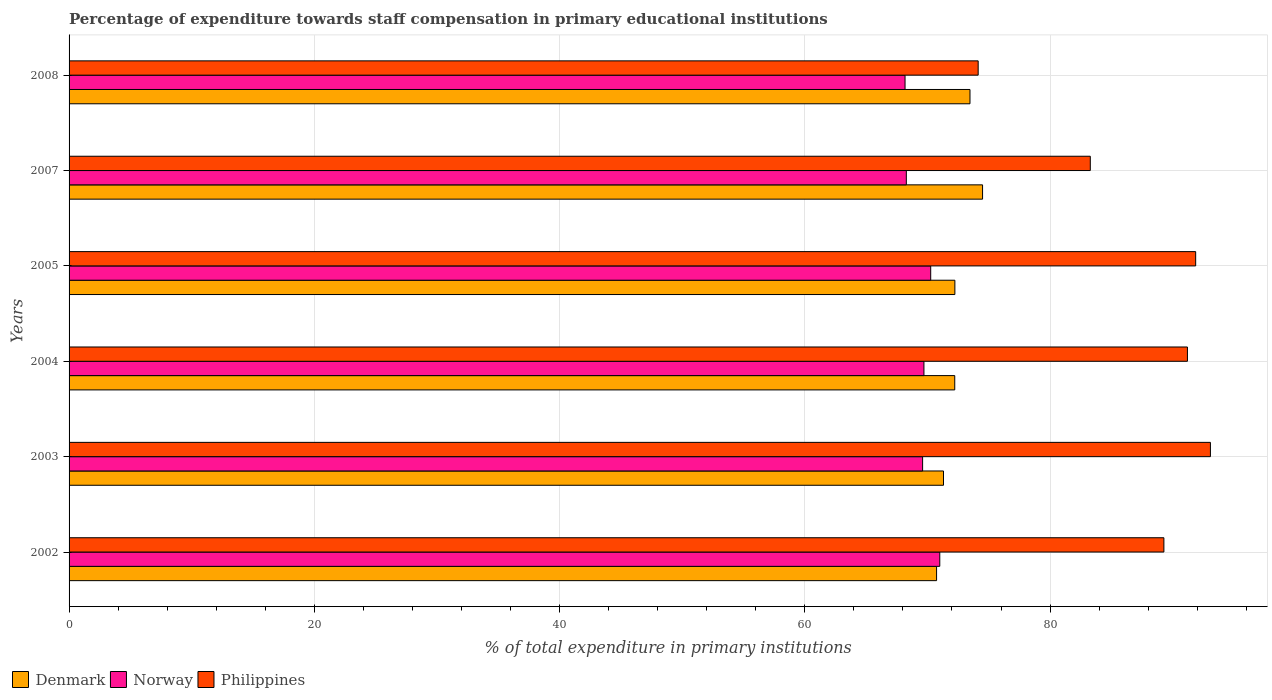How many bars are there on the 6th tick from the top?
Provide a succinct answer. 3. How many bars are there on the 2nd tick from the bottom?
Give a very brief answer. 3. What is the label of the 1st group of bars from the top?
Your response must be concise. 2008. In how many cases, is the number of bars for a given year not equal to the number of legend labels?
Offer a very short reply. 0. What is the percentage of expenditure towards staff compensation in Philippines in 2004?
Give a very brief answer. 91.2. Across all years, what is the maximum percentage of expenditure towards staff compensation in Norway?
Offer a terse response. 71.01. Across all years, what is the minimum percentage of expenditure towards staff compensation in Denmark?
Your response must be concise. 70.75. What is the total percentage of expenditure towards staff compensation in Denmark in the graph?
Offer a terse response. 434.49. What is the difference between the percentage of expenditure towards staff compensation in Philippines in 2003 and that in 2005?
Offer a very short reply. 1.2. What is the difference between the percentage of expenditure towards staff compensation in Norway in 2004 and the percentage of expenditure towards staff compensation in Philippines in 2005?
Keep it short and to the point. -22.16. What is the average percentage of expenditure towards staff compensation in Norway per year?
Provide a succinct answer. 69.51. In the year 2007, what is the difference between the percentage of expenditure towards staff compensation in Philippines and percentage of expenditure towards staff compensation in Denmark?
Provide a short and direct response. 8.79. What is the ratio of the percentage of expenditure towards staff compensation in Norway in 2002 to that in 2003?
Offer a terse response. 1.02. What is the difference between the highest and the second highest percentage of expenditure towards staff compensation in Denmark?
Your answer should be very brief. 1.03. What is the difference between the highest and the lowest percentage of expenditure towards staff compensation in Norway?
Ensure brevity in your answer.  2.83. In how many years, is the percentage of expenditure towards staff compensation in Denmark greater than the average percentage of expenditure towards staff compensation in Denmark taken over all years?
Your answer should be very brief. 2. Is the sum of the percentage of expenditure towards staff compensation in Philippines in 2005 and 2007 greater than the maximum percentage of expenditure towards staff compensation in Norway across all years?
Provide a succinct answer. Yes. What does the 2nd bar from the bottom in 2007 represents?
Provide a short and direct response. Norway. Are all the bars in the graph horizontal?
Your answer should be very brief. Yes. What is the difference between two consecutive major ticks on the X-axis?
Offer a terse response. 20. Does the graph contain any zero values?
Provide a succinct answer. No. Where does the legend appear in the graph?
Your answer should be compact. Bottom left. How are the legend labels stacked?
Offer a very short reply. Horizontal. What is the title of the graph?
Offer a terse response. Percentage of expenditure towards staff compensation in primary educational institutions. What is the label or title of the X-axis?
Provide a succinct answer. % of total expenditure in primary institutions. What is the % of total expenditure in primary institutions of Denmark in 2002?
Provide a short and direct response. 70.75. What is the % of total expenditure in primary institutions in Norway in 2002?
Ensure brevity in your answer.  71.01. What is the % of total expenditure in primary institutions in Philippines in 2002?
Offer a terse response. 89.28. What is the % of total expenditure in primary institutions in Denmark in 2003?
Give a very brief answer. 71.31. What is the % of total expenditure in primary institutions of Norway in 2003?
Your answer should be compact. 69.61. What is the % of total expenditure in primary institutions of Philippines in 2003?
Provide a succinct answer. 93.08. What is the % of total expenditure in primary institutions of Denmark in 2004?
Provide a succinct answer. 72.23. What is the % of total expenditure in primary institutions in Norway in 2004?
Provide a short and direct response. 69.71. What is the % of total expenditure in primary institutions in Philippines in 2004?
Give a very brief answer. 91.2. What is the % of total expenditure in primary institutions of Denmark in 2005?
Give a very brief answer. 72.24. What is the % of total expenditure in primary institutions of Norway in 2005?
Your response must be concise. 70.27. What is the % of total expenditure in primary institutions of Philippines in 2005?
Provide a short and direct response. 91.88. What is the % of total expenditure in primary institutions in Denmark in 2007?
Provide a succinct answer. 74.5. What is the % of total expenditure in primary institutions of Norway in 2007?
Your answer should be compact. 68.28. What is the % of total expenditure in primary institutions in Philippines in 2007?
Make the answer very short. 83.28. What is the % of total expenditure in primary institutions of Denmark in 2008?
Provide a short and direct response. 73.47. What is the % of total expenditure in primary institutions of Norway in 2008?
Offer a very short reply. 68.17. What is the % of total expenditure in primary institutions in Philippines in 2008?
Your answer should be very brief. 74.14. Across all years, what is the maximum % of total expenditure in primary institutions in Denmark?
Provide a short and direct response. 74.5. Across all years, what is the maximum % of total expenditure in primary institutions in Norway?
Offer a terse response. 71.01. Across all years, what is the maximum % of total expenditure in primary institutions of Philippines?
Keep it short and to the point. 93.08. Across all years, what is the minimum % of total expenditure in primary institutions of Denmark?
Offer a very short reply. 70.75. Across all years, what is the minimum % of total expenditure in primary institutions of Norway?
Make the answer very short. 68.17. Across all years, what is the minimum % of total expenditure in primary institutions of Philippines?
Provide a short and direct response. 74.14. What is the total % of total expenditure in primary institutions of Denmark in the graph?
Your answer should be very brief. 434.49. What is the total % of total expenditure in primary institutions of Norway in the graph?
Give a very brief answer. 417.05. What is the total % of total expenditure in primary institutions in Philippines in the graph?
Your answer should be compact. 522.86. What is the difference between the % of total expenditure in primary institutions of Denmark in 2002 and that in 2003?
Give a very brief answer. -0.56. What is the difference between the % of total expenditure in primary institutions of Norway in 2002 and that in 2003?
Offer a terse response. 1.4. What is the difference between the % of total expenditure in primary institutions of Philippines in 2002 and that in 2003?
Ensure brevity in your answer.  -3.79. What is the difference between the % of total expenditure in primary institutions in Denmark in 2002 and that in 2004?
Your response must be concise. -1.48. What is the difference between the % of total expenditure in primary institutions in Norway in 2002 and that in 2004?
Provide a short and direct response. 1.29. What is the difference between the % of total expenditure in primary institutions of Philippines in 2002 and that in 2004?
Offer a very short reply. -1.92. What is the difference between the % of total expenditure in primary institutions of Denmark in 2002 and that in 2005?
Offer a very short reply. -1.49. What is the difference between the % of total expenditure in primary institutions of Norway in 2002 and that in 2005?
Offer a very short reply. 0.74. What is the difference between the % of total expenditure in primary institutions in Philippines in 2002 and that in 2005?
Provide a succinct answer. -2.59. What is the difference between the % of total expenditure in primary institutions in Denmark in 2002 and that in 2007?
Offer a terse response. -3.75. What is the difference between the % of total expenditure in primary institutions in Norway in 2002 and that in 2007?
Offer a terse response. 2.73. What is the difference between the % of total expenditure in primary institutions of Philippines in 2002 and that in 2007?
Give a very brief answer. 6. What is the difference between the % of total expenditure in primary institutions of Denmark in 2002 and that in 2008?
Give a very brief answer. -2.72. What is the difference between the % of total expenditure in primary institutions in Norway in 2002 and that in 2008?
Your answer should be very brief. 2.83. What is the difference between the % of total expenditure in primary institutions in Philippines in 2002 and that in 2008?
Ensure brevity in your answer.  15.15. What is the difference between the % of total expenditure in primary institutions of Denmark in 2003 and that in 2004?
Ensure brevity in your answer.  -0.92. What is the difference between the % of total expenditure in primary institutions in Norway in 2003 and that in 2004?
Your answer should be very brief. -0.11. What is the difference between the % of total expenditure in primary institutions of Philippines in 2003 and that in 2004?
Keep it short and to the point. 1.87. What is the difference between the % of total expenditure in primary institutions of Denmark in 2003 and that in 2005?
Make the answer very short. -0.93. What is the difference between the % of total expenditure in primary institutions in Norway in 2003 and that in 2005?
Ensure brevity in your answer.  -0.66. What is the difference between the % of total expenditure in primary institutions of Philippines in 2003 and that in 2005?
Offer a very short reply. 1.2. What is the difference between the % of total expenditure in primary institutions of Denmark in 2003 and that in 2007?
Offer a terse response. -3.19. What is the difference between the % of total expenditure in primary institutions in Norway in 2003 and that in 2007?
Provide a succinct answer. 1.33. What is the difference between the % of total expenditure in primary institutions of Philippines in 2003 and that in 2007?
Make the answer very short. 9.8. What is the difference between the % of total expenditure in primary institutions of Denmark in 2003 and that in 2008?
Give a very brief answer. -2.16. What is the difference between the % of total expenditure in primary institutions in Norway in 2003 and that in 2008?
Provide a succinct answer. 1.43. What is the difference between the % of total expenditure in primary institutions in Philippines in 2003 and that in 2008?
Ensure brevity in your answer.  18.94. What is the difference between the % of total expenditure in primary institutions of Denmark in 2004 and that in 2005?
Your answer should be very brief. -0.01. What is the difference between the % of total expenditure in primary institutions of Norway in 2004 and that in 2005?
Make the answer very short. -0.55. What is the difference between the % of total expenditure in primary institutions in Philippines in 2004 and that in 2005?
Provide a short and direct response. -0.67. What is the difference between the % of total expenditure in primary institutions in Denmark in 2004 and that in 2007?
Give a very brief answer. -2.27. What is the difference between the % of total expenditure in primary institutions in Norway in 2004 and that in 2007?
Provide a short and direct response. 1.44. What is the difference between the % of total expenditure in primary institutions in Philippines in 2004 and that in 2007?
Provide a succinct answer. 7.92. What is the difference between the % of total expenditure in primary institutions of Denmark in 2004 and that in 2008?
Ensure brevity in your answer.  -1.24. What is the difference between the % of total expenditure in primary institutions in Norway in 2004 and that in 2008?
Offer a very short reply. 1.54. What is the difference between the % of total expenditure in primary institutions in Philippines in 2004 and that in 2008?
Provide a succinct answer. 17.07. What is the difference between the % of total expenditure in primary institutions of Denmark in 2005 and that in 2007?
Your response must be concise. -2.26. What is the difference between the % of total expenditure in primary institutions of Norway in 2005 and that in 2007?
Provide a succinct answer. 1.99. What is the difference between the % of total expenditure in primary institutions of Philippines in 2005 and that in 2007?
Give a very brief answer. 8.59. What is the difference between the % of total expenditure in primary institutions in Denmark in 2005 and that in 2008?
Make the answer very short. -1.23. What is the difference between the % of total expenditure in primary institutions in Norway in 2005 and that in 2008?
Provide a succinct answer. 2.09. What is the difference between the % of total expenditure in primary institutions in Philippines in 2005 and that in 2008?
Ensure brevity in your answer.  17.74. What is the difference between the % of total expenditure in primary institutions in Denmark in 2007 and that in 2008?
Provide a short and direct response. 1.03. What is the difference between the % of total expenditure in primary institutions of Norway in 2007 and that in 2008?
Offer a very short reply. 0.11. What is the difference between the % of total expenditure in primary institutions in Philippines in 2007 and that in 2008?
Offer a terse response. 9.14. What is the difference between the % of total expenditure in primary institutions in Denmark in 2002 and the % of total expenditure in primary institutions in Norway in 2003?
Offer a terse response. 1.14. What is the difference between the % of total expenditure in primary institutions in Denmark in 2002 and the % of total expenditure in primary institutions in Philippines in 2003?
Provide a succinct answer. -22.33. What is the difference between the % of total expenditure in primary institutions of Norway in 2002 and the % of total expenditure in primary institutions of Philippines in 2003?
Provide a succinct answer. -22.07. What is the difference between the % of total expenditure in primary institutions of Denmark in 2002 and the % of total expenditure in primary institutions of Norway in 2004?
Offer a terse response. 1.03. What is the difference between the % of total expenditure in primary institutions of Denmark in 2002 and the % of total expenditure in primary institutions of Philippines in 2004?
Your answer should be very brief. -20.46. What is the difference between the % of total expenditure in primary institutions in Norway in 2002 and the % of total expenditure in primary institutions in Philippines in 2004?
Provide a short and direct response. -20.2. What is the difference between the % of total expenditure in primary institutions in Denmark in 2002 and the % of total expenditure in primary institutions in Norway in 2005?
Your response must be concise. 0.48. What is the difference between the % of total expenditure in primary institutions in Denmark in 2002 and the % of total expenditure in primary institutions in Philippines in 2005?
Give a very brief answer. -21.13. What is the difference between the % of total expenditure in primary institutions in Norway in 2002 and the % of total expenditure in primary institutions in Philippines in 2005?
Provide a succinct answer. -20.87. What is the difference between the % of total expenditure in primary institutions of Denmark in 2002 and the % of total expenditure in primary institutions of Norway in 2007?
Make the answer very short. 2.47. What is the difference between the % of total expenditure in primary institutions in Denmark in 2002 and the % of total expenditure in primary institutions in Philippines in 2007?
Offer a very short reply. -12.54. What is the difference between the % of total expenditure in primary institutions in Norway in 2002 and the % of total expenditure in primary institutions in Philippines in 2007?
Provide a short and direct response. -12.27. What is the difference between the % of total expenditure in primary institutions of Denmark in 2002 and the % of total expenditure in primary institutions of Norway in 2008?
Your answer should be compact. 2.57. What is the difference between the % of total expenditure in primary institutions in Denmark in 2002 and the % of total expenditure in primary institutions in Philippines in 2008?
Give a very brief answer. -3.39. What is the difference between the % of total expenditure in primary institutions of Norway in 2002 and the % of total expenditure in primary institutions of Philippines in 2008?
Keep it short and to the point. -3.13. What is the difference between the % of total expenditure in primary institutions of Denmark in 2003 and the % of total expenditure in primary institutions of Norway in 2004?
Offer a terse response. 1.6. What is the difference between the % of total expenditure in primary institutions of Denmark in 2003 and the % of total expenditure in primary institutions of Philippines in 2004?
Keep it short and to the point. -19.89. What is the difference between the % of total expenditure in primary institutions in Norway in 2003 and the % of total expenditure in primary institutions in Philippines in 2004?
Keep it short and to the point. -21.6. What is the difference between the % of total expenditure in primary institutions of Denmark in 2003 and the % of total expenditure in primary institutions of Norway in 2005?
Offer a terse response. 1.04. What is the difference between the % of total expenditure in primary institutions of Denmark in 2003 and the % of total expenditure in primary institutions of Philippines in 2005?
Make the answer very short. -20.57. What is the difference between the % of total expenditure in primary institutions in Norway in 2003 and the % of total expenditure in primary institutions in Philippines in 2005?
Your answer should be compact. -22.27. What is the difference between the % of total expenditure in primary institutions in Denmark in 2003 and the % of total expenditure in primary institutions in Norway in 2007?
Keep it short and to the point. 3.03. What is the difference between the % of total expenditure in primary institutions in Denmark in 2003 and the % of total expenditure in primary institutions in Philippines in 2007?
Provide a short and direct response. -11.97. What is the difference between the % of total expenditure in primary institutions in Norway in 2003 and the % of total expenditure in primary institutions in Philippines in 2007?
Offer a very short reply. -13.67. What is the difference between the % of total expenditure in primary institutions of Denmark in 2003 and the % of total expenditure in primary institutions of Norway in 2008?
Your answer should be very brief. 3.14. What is the difference between the % of total expenditure in primary institutions in Denmark in 2003 and the % of total expenditure in primary institutions in Philippines in 2008?
Keep it short and to the point. -2.83. What is the difference between the % of total expenditure in primary institutions of Norway in 2003 and the % of total expenditure in primary institutions of Philippines in 2008?
Ensure brevity in your answer.  -4.53. What is the difference between the % of total expenditure in primary institutions of Denmark in 2004 and the % of total expenditure in primary institutions of Norway in 2005?
Offer a very short reply. 1.96. What is the difference between the % of total expenditure in primary institutions in Denmark in 2004 and the % of total expenditure in primary institutions in Philippines in 2005?
Offer a terse response. -19.65. What is the difference between the % of total expenditure in primary institutions in Norway in 2004 and the % of total expenditure in primary institutions in Philippines in 2005?
Make the answer very short. -22.16. What is the difference between the % of total expenditure in primary institutions in Denmark in 2004 and the % of total expenditure in primary institutions in Norway in 2007?
Your response must be concise. 3.95. What is the difference between the % of total expenditure in primary institutions in Denmark in 2004 and the % of total expenditure in primary institutions in Philippines in 2007?
Your answer should be compact. -11.05. What is the difference between the % of total expenditure in primary institutions in Norway in 2004 and the % of total expenditure in primary institutions in Philippines in 2007?
Your answer should be very brief. -13.57. What is the difference between the % of total expenditure in primary institutions of Denmark in 2004 and the % of total expenditure in primary institutions of Norway in 2008?
Make the answer very short. 4.05. What is the difference between the % of total expenditure in primary institutions in Denmark in 2004 and the % of total expenditure in primary institutions in Philippines in 2008?
Ensure brevity in your answer.  -1.91. What is the difference between the % of total expenditure in primary institutions in Norway in 2004 and the % of total expenditure in primary institutions in Philippines in 2008?
Make the answer very short. -4.42. What is the difference between the % of total expenditure in primary institutions in Denmark in 2005 and the % of total expenditure in primary institutions in Norway in 2007?
Your answer should be compact. 3.96. What is the difference between the % of total expenditure in primary institutions in Denmark in 2005 and the % of total expenditure in primary institutions in Philippines in 2007?
Your answer should be compact. -11.04. What is the difference between the % of total expenditure in primary institutions of Norway in 2005 and the % of total expenditure in primary institutions of Philippines in 2007?
Offer a terse response. -13.02. What is the difference between the % of total expenditure in primary institutions in Denmark in 2005 and the % of total expenditure in primary institutions in Norway in 2008?
Offer a terse response. 4.06. What is the difference between the % of total expenditure in primary institutions of Denmark in 2005 and the % of total expenditure in primary institutions of Philippines in 2008?
Your answer should be very brief. -1.9. What is the difference between the % of total expenditure in primary institutions in Norway in 2005 and the % of total expenditure in primary institutions in Philippines in 2008?
Provide a short and direct response. -3.87. What is the difference between the % of total expenditure in primary institutions in Denmark in 2007 and the % of total expenditure in primary institutions in Norway in 2008?
Offer a terse response. 6.32. What is the difference between the % of total expenditure in primary institutions of Denmark in 2007 and the % of total expenditure in primary institutions of Philippines in 2008?
Make the answer very short. 0.36. What is the difference between the % of total expenditure in primary institutions of Norway in 2007 and the % of total expenditure in primary institutions of Philippines in 2008?
Provide a succinct answer. -5.86. What is the average % of total expenditure in primary institutions in Denmark per year?
Provide a short and direct response. 72.41. What is the average % of total expenditure in primary institutions of Norway per year?
Give a very brief answer. 69.51. What is the average % of total expenditure in primary institutions in Philippines per year?
Ensure brevity in your answer.  87.14. In the year 2002, what is the difference between the % of total expenditure in primary institutions of Denmark and % of total expenditure in primary institutions of Norway?
Your answer should be very brief. -0.26. In the year 2002, what is the difference between the % of total expenditure in primary institutions in Denmark and % of total expenditure in primary institutions in Philippines?
Provide a short and direct response. -18.54. In the year 2002, what is the difference between the % of total expenditure in primary institutions in Norway and % of total expenditure in primary institutions in Philippines?
Your answer should be compact. -18.28. In the year 2003, what is the difference between the % of total expenditure in primary institutions of Denmark and % of total expenditure in primary institutions of Norway?
Make the answer very short. 1.7. In the year 2003, what is the difference between the % of total expenditure in primary institutions of Denmark and % of total expenditure in primary institutions of Philippines?
Your answer should be very brief. -21.77. In the year 2003, what is the difference between the % of total expenditure in primary institutions of Norway and % of total expenditure in primary institutions of Philippines?
Keep it short and to the point. -23.47. In the year 2004, what is the difference between the % of total expenditure in primary institutions of Denmark and % of total expenditure in primary institutions of Norway?
Ensure brevity in your answer.  2.51. In the year 2004, what is the difference between the % of total expenditure in primary institutions of Denmark and % of total expenditure in primary institutions of Philippines?
Give a very brief answer. -18.98. In the year 2004, what is the difference between the % of total expenditure in primary institutions in Norway and % of total expenditure in primary institutions in Philippines?
Your answer should be compact. -21.49. In the year 2005, what is the difference between the % of total expenditure in primary institutions in Denmark and % of total expenditure in primary institutions in Norway?
Ensure brevity in your answer.  1.97. In the year 2005, what is the difference between the % of total expenditure in primary institutions of Denmark and % of total expenditure in primary institutions of Philippines?
Your response must be concise. -19.64. In the year 2005, what is the difference between the % of total expenditure in primary institutions in Norway and % of total expenditure in primary institutions in Philippines?
Provide a succinct answer. -21.61. In the year 2007, what is the difference between the % of total expenditure in primary institutions of Denmark and % of total expenditure in primary institutions of Norway?
Offer a very short reply. 6.22. In the year 2007, what is the difference between the % of total expenditure in primary institutions of Denmark and % of total expenditure in primary institutions of Philippines?
Offer a very short reply. -8.79. In the year 2007, what is the difference between the % of total expenditure in primary institutions in Norway and % of total expenditure in primary institutions in Philippines?
Offer a terse response. -15. In the year 2008, what is the difference between the % of total expenditure in primary institutions of Denmark and % of total expenditure in primary institutions of Norway?
Provide a succinct answer. 5.3. In the year 2008, what is the difference between the % of total expenditure in primary institutions in Denmark and % of total expenditure in primary institutions in Philippines?
Keep it short and to the point. -0.67. In the year 2008, what is the difference between the % of total expenditure in primary institutions in Norway and % of total expenditure in primary institutions in Philippines?
Your answer should be compact. -5.96. What is the ratio of the % of total expenditure in primary institutions in Denmark in 2002 to that in 2003?
Offer a terse response. 0.99. What is the ratio of the % of total expenditure in primary institutions in Norway in 2002 to that in 2003?
Provide a short and direct response. 1.02. What is the ratio of the % of total expenditure in primary institutions in Philippines in 2002 to that in 2003?
Your answer should be very brief. 0.96. What is the ratio of the % of total expenditure in primary institutions of Denmark in 2002 to that in 2004?
Ensure brevity in your answer.  0.98. What is the ratio of the % of total expenditure in primary institutions in Norway in 2002 to that in 2004?
Your answer should be compact. 1.02. What is the ratio of the % of total expenditure in primary institutions of Philippines in 2002 to that in 2004?
Give a very brief answer. 0.98. What is the ratio of the % of total expenditure in primary institutions in Denmark in 2002 to that in 2005?
Ensure brevity in your answer.  0.98. What is the ratio of the % of total expenditure in primary institutions of Norway in 2002 to that in 2005?
Your answer should be very brief. 1.01. What is the ratio of the % of total expenditure in primary institutions of Philippines in 2002 to that in 2005?
Provide a succinct answer. 0.97. What is the ratio of the % of total expenditure in primary institutions of Denmark in 2002 to that in 2007?
Offer a terse response. 0.95. What is the ratio of the % of total expenditure in primary institutions in Norway in 2002 to that in 2007?
Your answer should be very brief. 1.04. What is the ratio of the % of total expenditure in primary institutions of Philippines in 2002 to that in 2007?
Your answer should be compact. 1.07. What is the ratio of the % of total expenditure in primary institutions of Denmark in 2002 to that in 2008?
Make the answer very short. 0.96. What is the ratio of the % of total expenditure in primary institutions of Norway in 2002 to that in 2008?
Make the answer very short. 1.04. What is the ratio of the % of total expenditure in primary institutions in Philippines in 2002 to that in 2008?
Provide a short and direct response. 1.2. What is the ratio of the % of total expenditure in primary institutions of Denmark in 2003 to that in 2004?
Your answer should be very brief. 0.99. What is the ratio of the % of total expenditure in primary institutions in Philippines in 2003 to that in 2004?
Your answer should be very brief. 1.02. What is the ratio of the % of total expenditure in primary institutions in Denmark in 2003 to that in 2005?
Keep it short and to the point. 0.99. What is the ratio of the % of total expenditure in primary institutions in Norway in 2003 to that in 2005?
Provide a succinct answer. 0.99. What is the ratio of the % of total expenditure in primary institutions of Philippines in 2003 to that in 2005?
Your answer should be compact. 1.01. What is the ratio of the % of total expenditure in primary institutions in Denmark in 2003 to that in 2007?
Keep it short and to the point. 0.96. What is the ratio of the % of total expenditure in primary institutions in Norway in 2003 to that in 2007?
Make the answer very short. 1.02. What is the ratio of the % of total expenditure in primary institutions in Philippines in 2003 to that in 2007?
Your answer should be compact. 1.12. What is the ratio of the % of total expenditure in primary institutions of Denmark in 2003 to that in 2008?
Give a very brief answer. 0.97. What is the ratio of the % of total expenditure in primary institutions of Norway in 2003 to that in 2008?
Your answer should be compact. 1.02. What is the ratio of the % of total expenditure in primary institutions of Philippines in 2003 to that in 2008?
Offer a very short reply. 1.26. What is the ratio of the % of total expenditure in primary institutions in Norway in 2004 to that in 2005?
Give a very brief answer. 0.99. What is the ratio of the % of total expenditure in primary institutions of Philippines in 2004 to that in 2005?
Your response must be concise. 0.99. What is the ratio of the % of total expenditure in primary institutions of Denmark in 2004 to that in 2007?
Your answer should be very brief. 0.97. What is the ratio of the % of total expenditure in primary institutions of Norway in 2004 to that in 2007?
Make the answer very short. 1.02. What is the ratio of the % of total expenditure in primary institutions of Philippines in 2004 to that in 2007?
Offer a terse response. 1.1. What is the ratio of the % of total expenditure in primary institutions in Denmark in 2004 to that in 2008?
Your answer should be very brief. 0.98. What is the ratio of the % of total expenditure in primary institutions in Norway in 2004 to that in 2008?
Your answer should be compact. 1.02. What is the ratio of the % of total expenditure in primary institutions of Philippines in 2004 to that in 2008?
Your response must be concise. 1.23. What is the ratio of the % of total expenditure in primary institutions of Denmark in 2005 to that in 2007?
Your answer should be compact. 0.97. What is the ratio of the % of total expenditure in primary institutions in Norway in 2005 to that in 2007?
Keep it short and to the point. 1.03. What is the ratio of the % of total expenditure in primary institutions of Philippines in 2005 to that in 2007?
Give a very brief answer. 1.1. What is the ratio of the % of total expenditure in primary institutions of Denmark in 2005 to that in 2008?
Keep it short and to the point. 0.98. What is the ratio of the % of total expenditure in primary institutions in Norway in 2005 to that in 2008?
Ensure brevity in your answer.  1.03. What is the ratio of the % of total expenditure in primary institutions in Philippines in 2005 to that in 2008?
Your response must be concise. 1.24. What is the ratio of the % of total expenditure in primary institutions of Philippines in 2007 to that in 2008?
Give a very brief answer. 1.12. What is the difference between the highest and the second highest % of total expenditure in primary institutions of Denmark?
Your response must be concise. 1.03. What is the difference between the highest and the second highest % of total expenditure in primary institutions of Norway?
Offer a terse response. 0.74. What is the difference between the highest and the second highest % of total expenditure in primary institutions in Philippines?
Provide a succinct answer. 1.2. What is the difference between the highest and the lowest % of total expenditure in primary institutions of Denmark?
Provide a short and direct response. 3.75. What is the difference between the highest and the lowest % of total expenditure in primary institutions in Norway?
Your response must be concise. 2.83. What is the difference between the highest and the lowest % of total expenditure in primary institutions in Philippines?
Provide a succinct answer. 18.94. 